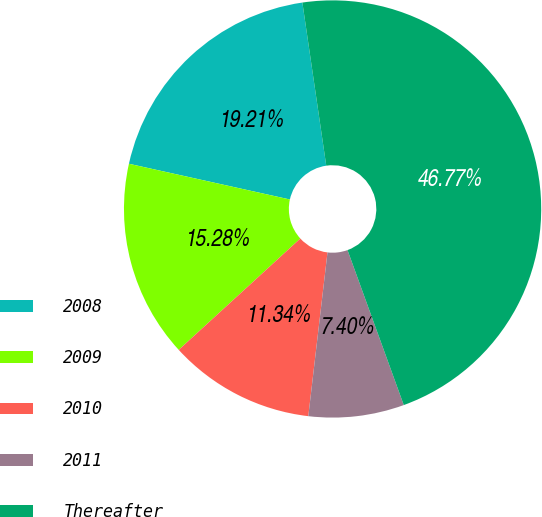<chart> <loc_0><loc_0><loc_500><loc_500><pie_chart><fcel>2008<fcel>2009<fcel>2010<fcel>2011<fcel>Thereafter<nl><fcel>19.21%<fcel>15.28%<fcel>11.34%<fcel>7.4%<fcel>46.77%<nl></chart> 